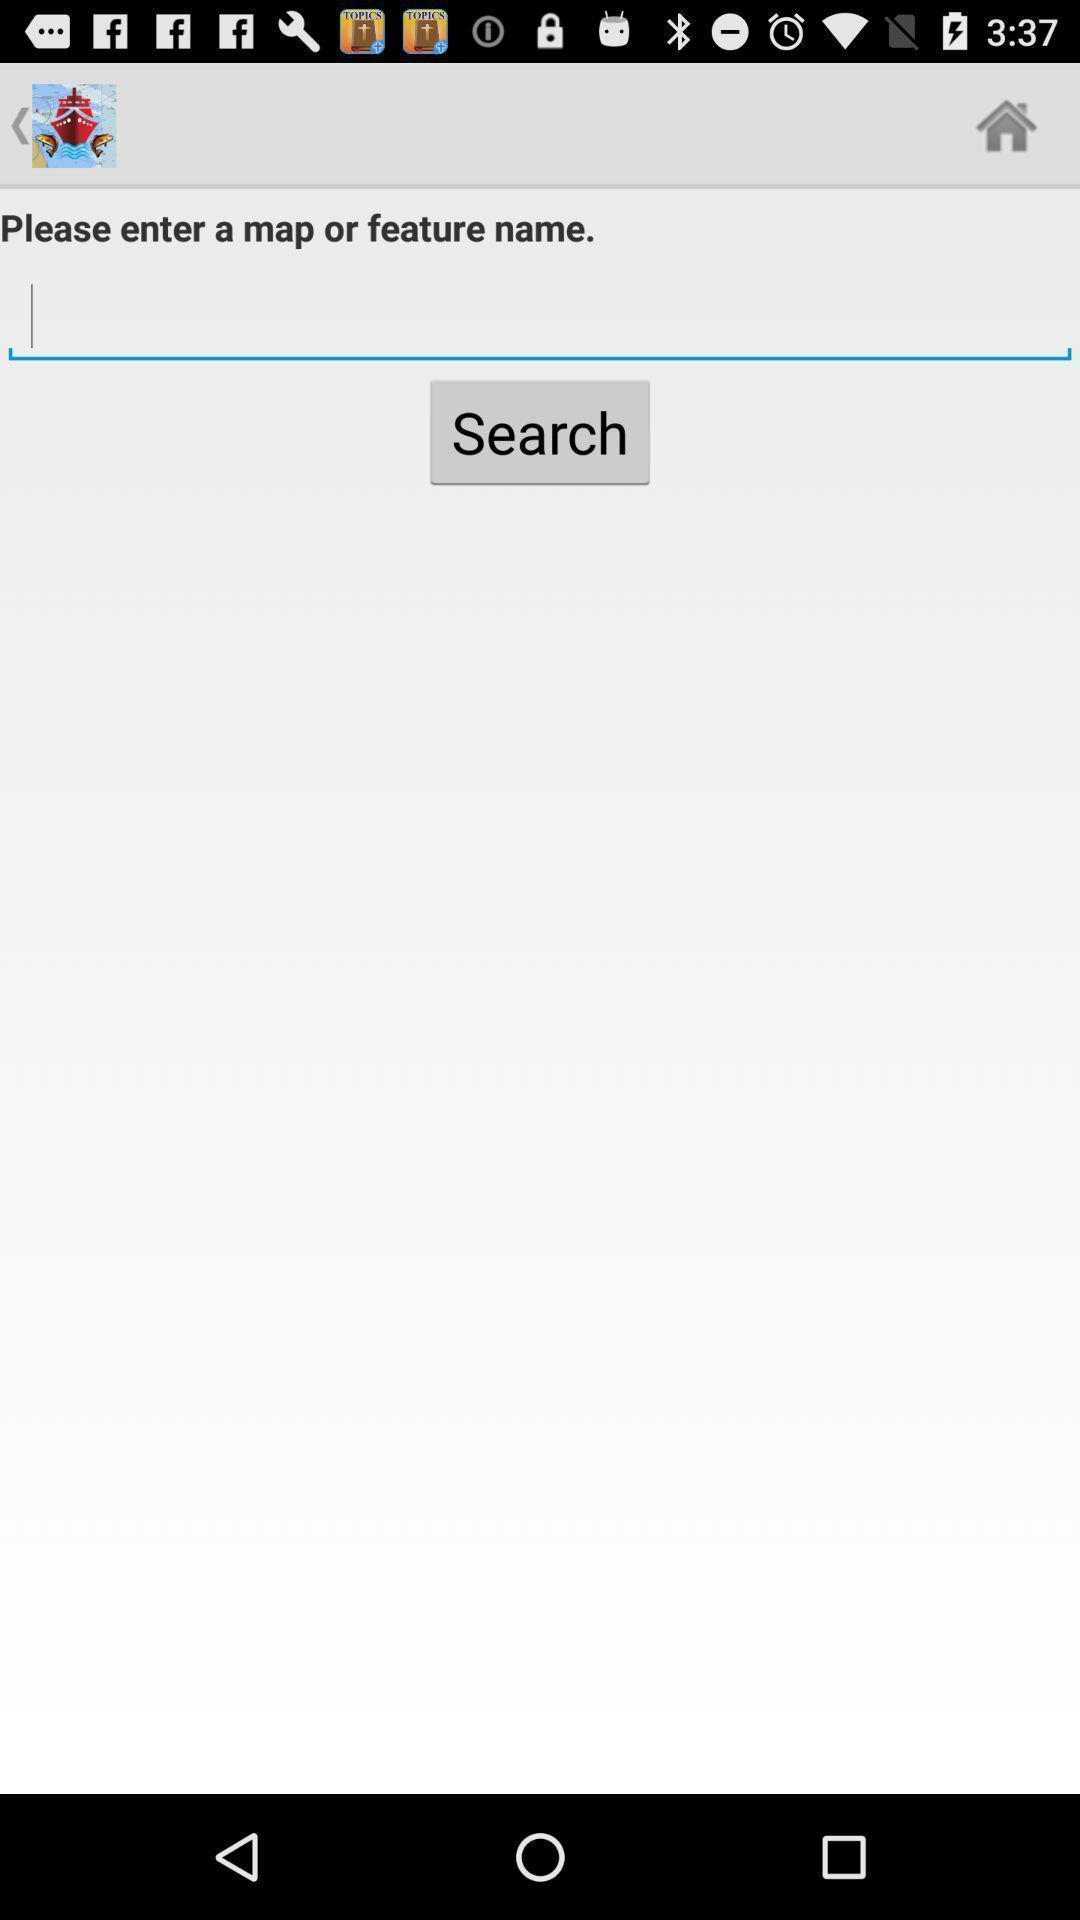Tell me about the visual elements in this screen capture. Search box to find map in the application. 